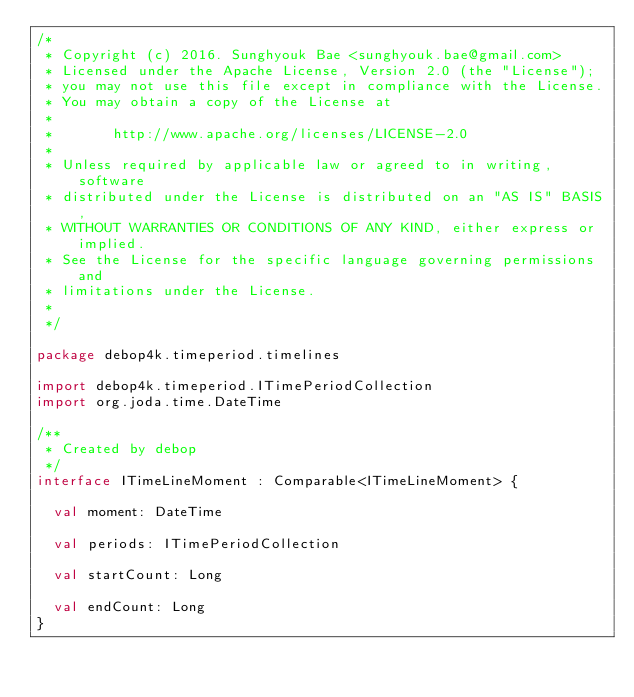<code> <loc_0><loc_0><loc_500><loc_500><_Kotlin_>/*
 * Copyright (c) 2016. Sunghyouk Bae <sunghyouk.bae@gmail.com>
 * Licensed under the Apache License, Version 2.0 (the "License");
 * you may not use this file except in compliance with the License.
 * You may obtain a copy of the License at
 *
 *       http://www.apache.org/licenses/LICENSE-2.0
 *
 * Unless required by applicable law or agreed to in writing, software
 * distributed under the License is distributed on an "AS IS" BASIS,
 * WITHOUT WARRANTIES OR CONDITIONS OF ANY KIND, either express or implied.
 * See the License for the specific language governing permissions and
 * limitations under the License.
 *
 */

package debop4k.timeperiod.timelines

import debop4k.timeperiod.ITimePeriodCollection
import org.joda.time.DateTime

/**
 * Created by debop
 */
interface ITimeLineMoment : Comparable<ITimeLineMoment> {

  val moment: DateTime

  val periods: ITimePeriodCollection

  val startCount: Long

  val endCount: Long
}</code> 